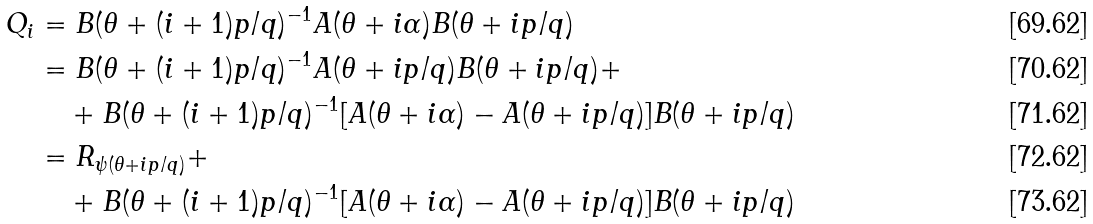Convert formula to latex. <formula><loc_0><loc_0><loc_500><loc_500>Q _ { i } & = B ( \theta + ( i + 1 ) p / q ) ^ { - 1 } A ( \theta + i \alpha ) B ( \theta + i p / q ) \\ & = B ( \theta + ( i + 1 ) p / q ) ^ { - 1 } A ( \theta + i p / q ) B ( \theta + i p / q ) + \\ & \quad + B ( \theta + ( i + 1 ) p / q ) ^ { - 1 } [ A ( \theta + i \alpha ) - A ( \theta + i p / q ) ] B ( \theta + i p / q ) \\ & = R _ { \psi ( \theta + i p / q ) } + \\ & \quad + B ( \theta + ( i + 1 ) p / q ) ^ { - 1 } [ A ( \theta + i \alpha ) - A ( \theta + i p / q ) ] B ( \theta + i p / q )</formula> 